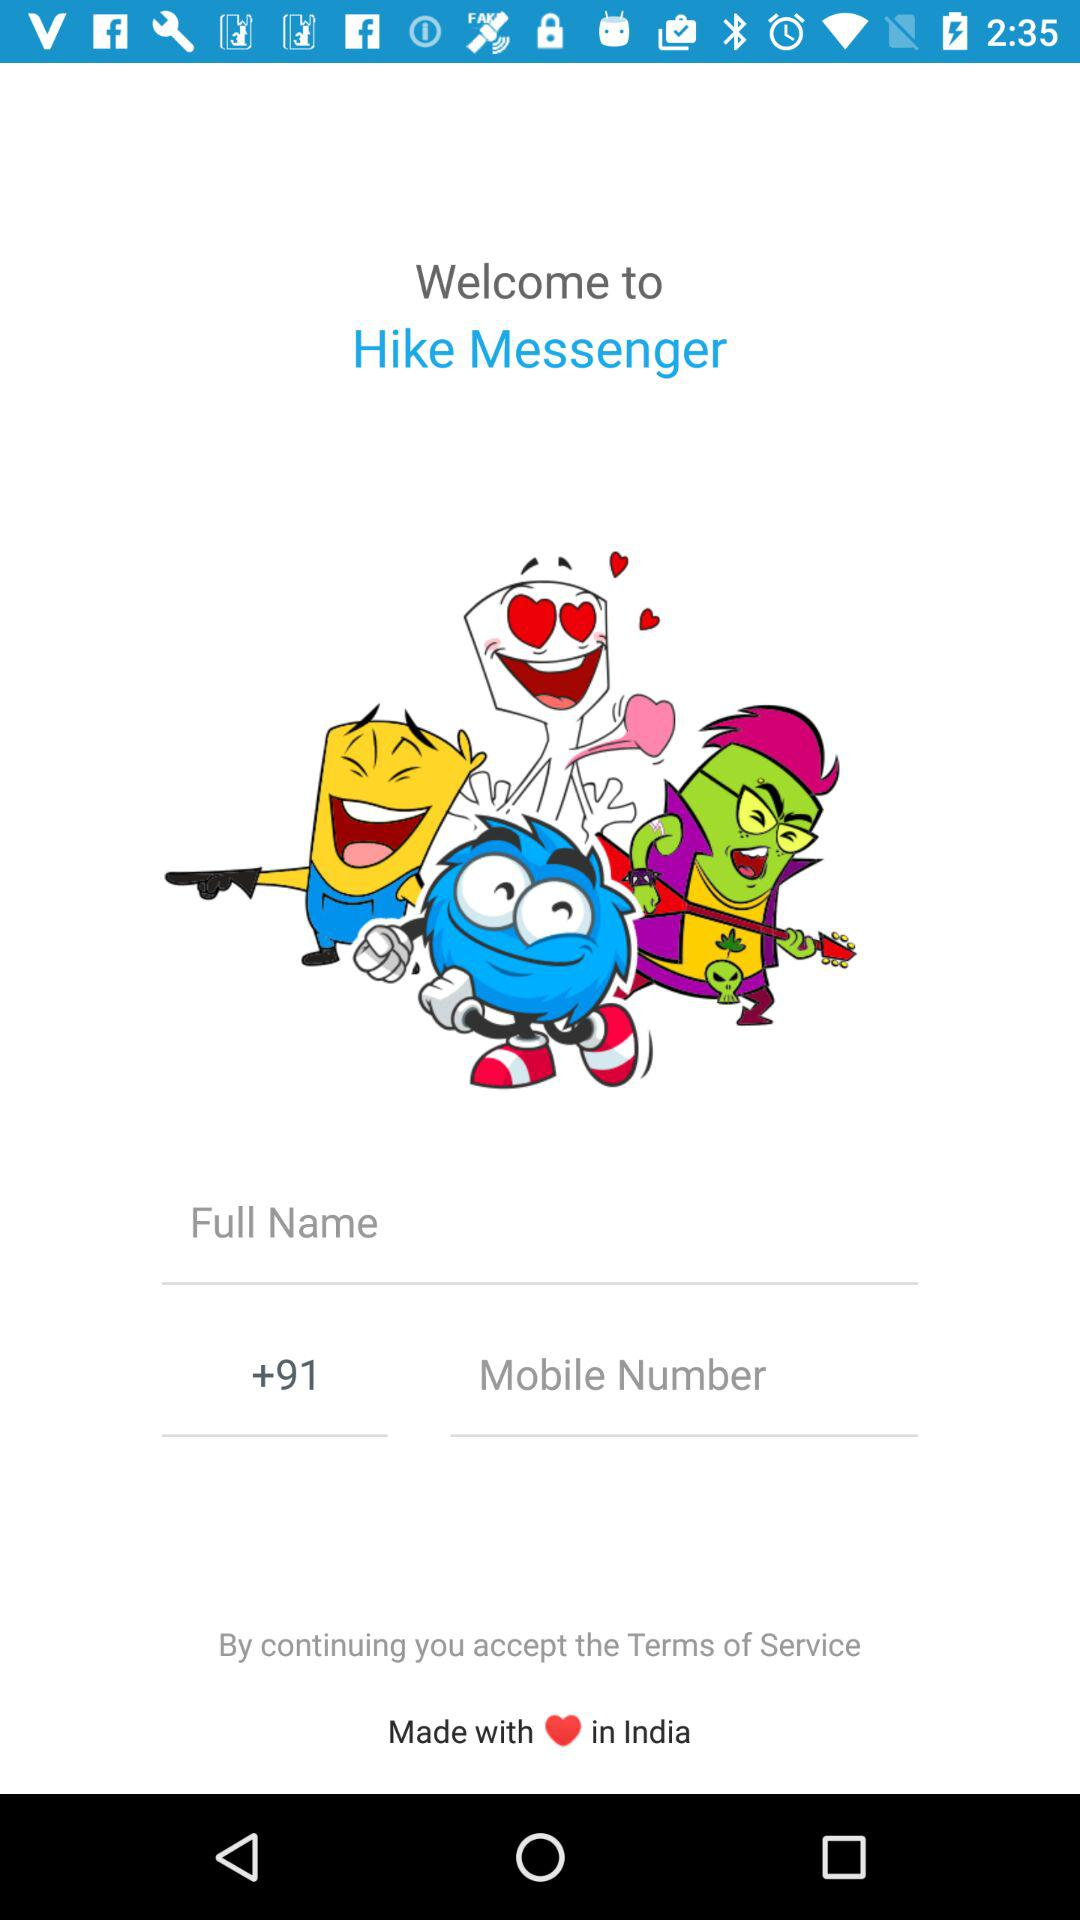What is the name of the application? The name of the application is "Hike Messenger". 